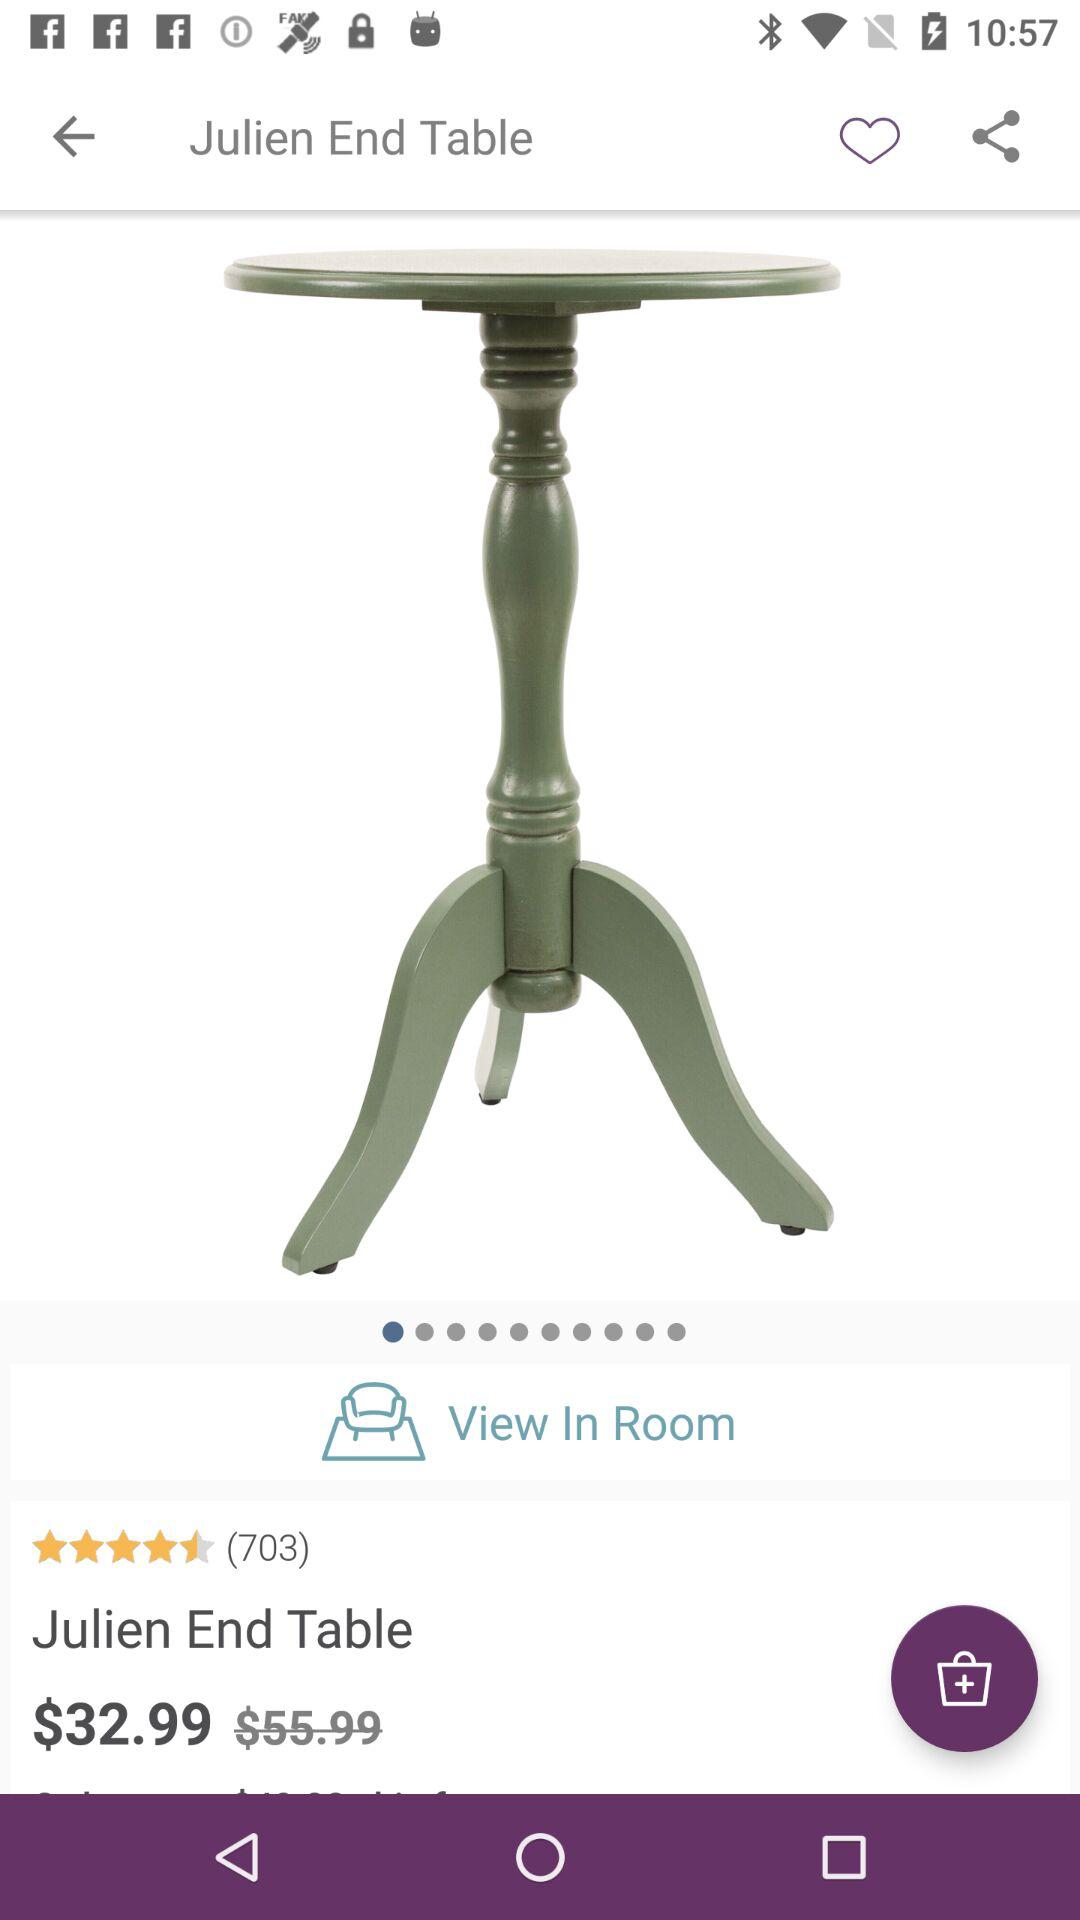What is the rating of the "Julien End Table"? The rating is 4.5 stars. 